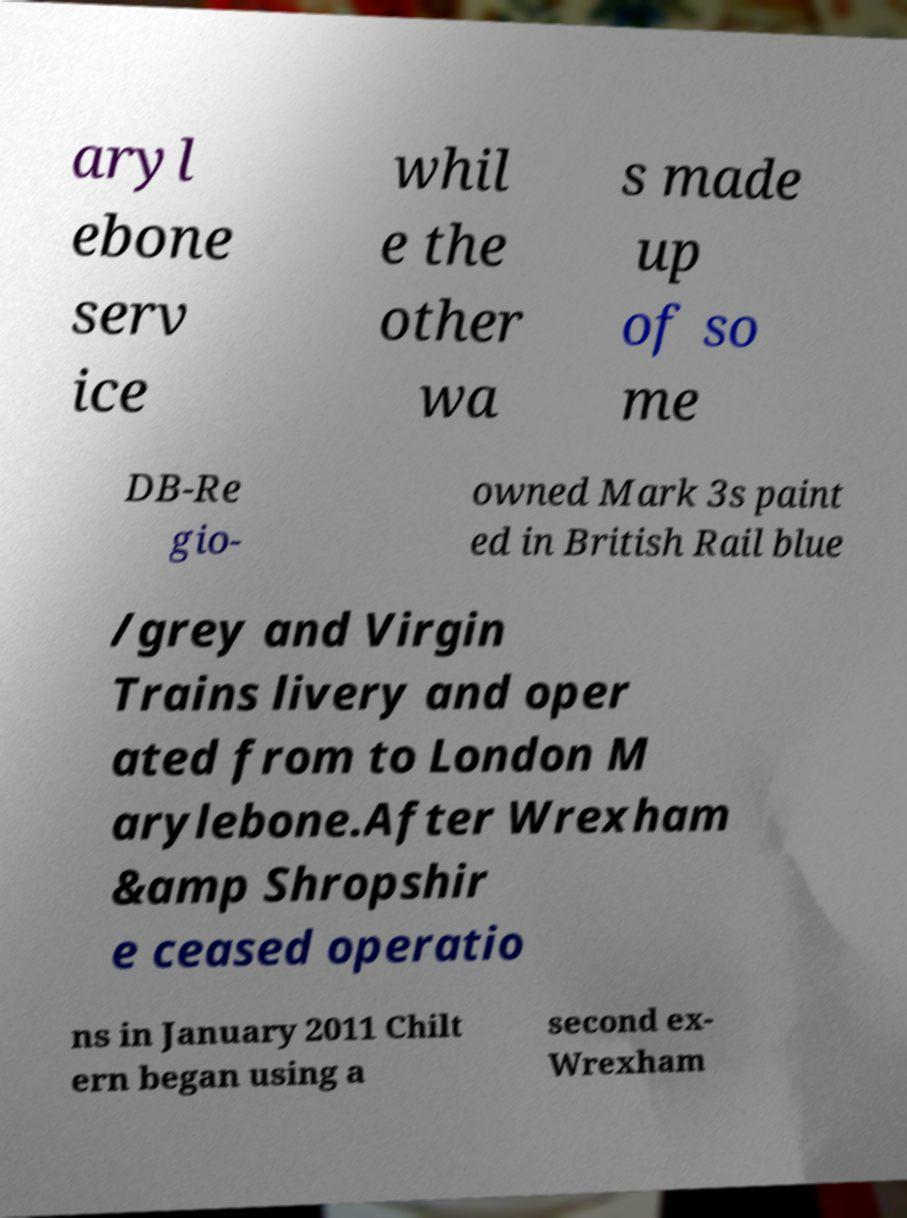There's text embedded in this image that I need extracted. Can you transcribe it verbatim? aryl ebone serv ice whil e the other wa s made up of so me DB-Re gio- owned Mark 3s paint ed in British Rail blue /grey and Virgin Trains livery and oper ated from to London M arylebone.After Wrexham &amp Shropshir e ceased operatio ns in January 2011 Chilt ern began using a second ex- Wrexham 